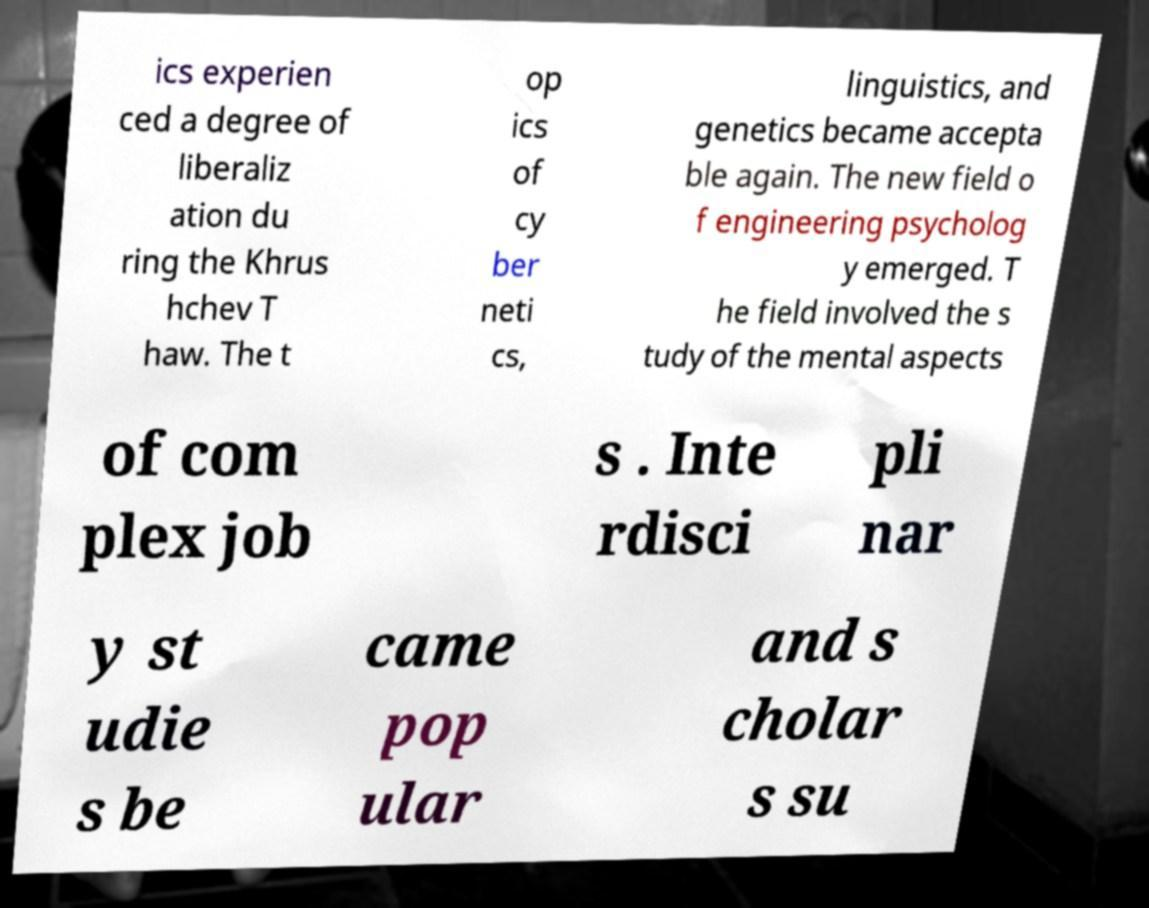Can you accurately transcribe the text from the provided image for me? ics experien ced a degree of liberaliz ation du ring the Khrus hchev T haw. The t op ics of cy ber neti cs, linguistics, and genetics became accepta ble again. The new field o f engineering psycholog y emerged. T he field involved the s tudy of the mental aspects of com plex job s . Inte rdisci pli nar y st udie s be came pop ular and s cholar s su 